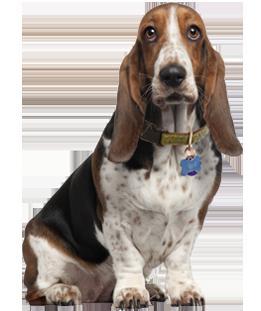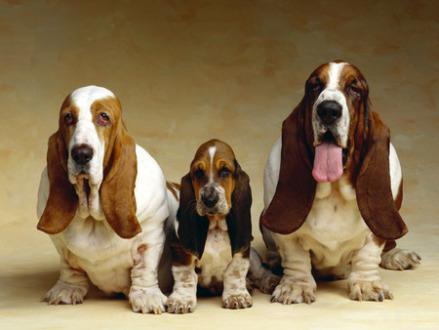The first image is the image on the left, the second image is the image on the right. Evaluate the accuracy of this statement regarding the images: "Exactly one dog tongue can be seen in one of the images.". Is it true? Answer yes or no. Yes. 